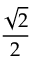<formula> <loc_0><loc_0><loc_500><loc_500>\frac { \sqrt { 2 } } { 2 }</formula> 